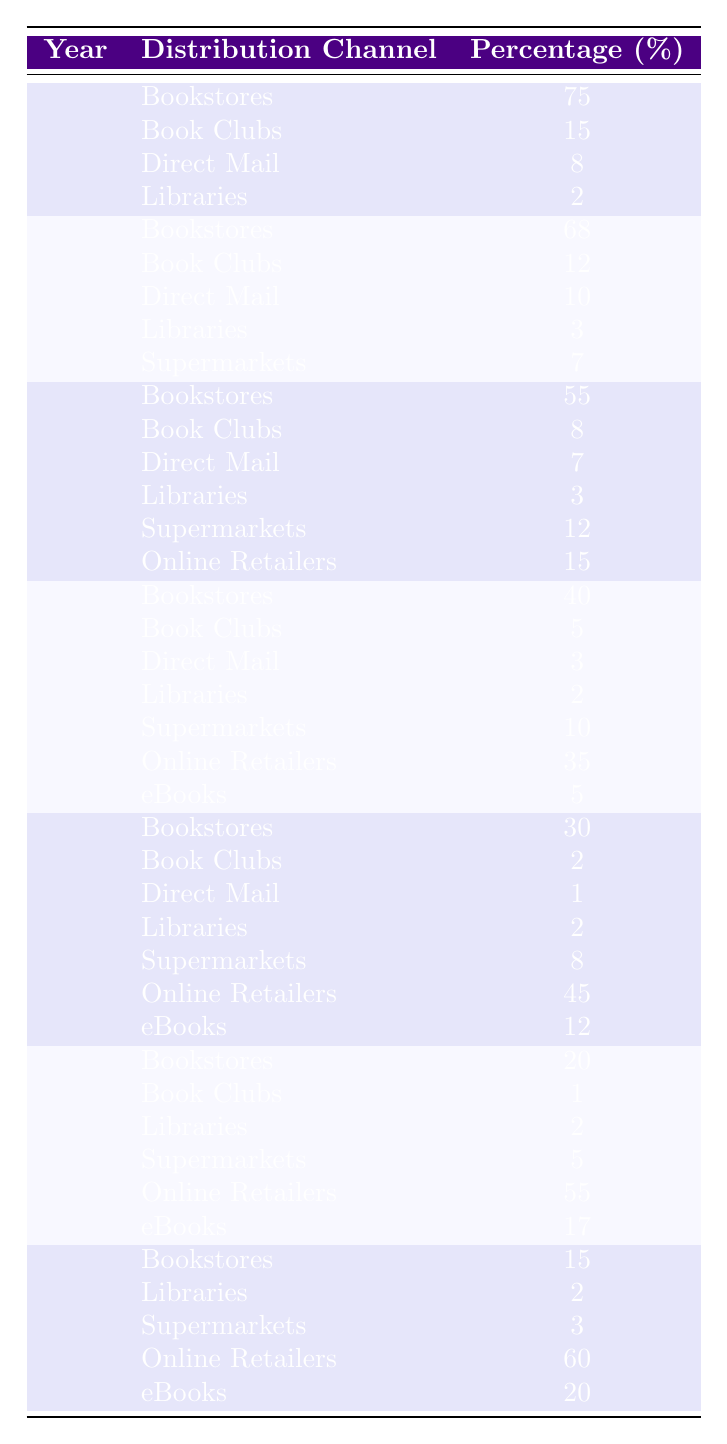What percentage of books were sold through bookstores in 1990? The table shows that in 1990, the percentage of books sold through bookstores was listed as 55%.
Answer: 55% In which year did online retailers first appear, and what was their percentage of books sold? Online retailers first appeared in 1990 with a percentage of 15% for books sold.
Answer: 1990, 15% What was the percentage increase in books sold through online retailers from 2000 to 2010? The percentage of books sold through online retailers was 35% in 2000 and increased to 45% in 2010. The increase is calculated as \(45 - 35 = 10\) percentage points.
Answer: 10 Which distribution channel had the highest percentage in 1980? In 1980, bookstores had the highest percentage of 68%.
Answer: 68% What was the reduction in percentage of books sold through bookstores from 1970 to 2023? The percentage of books sold through bookstores decreased from 75% in 1970 to 15% in 2023. The reduction is \(75 - 15 = 60\) percentage points.
Answer: 60 What is the total percentage of books sold through supermarkets across all years combined? The percentages for supermarkets across the years are: 0% (not listed in 1970 and 1980), 12% (1990), 10% (2000), 8% (2010), 5% (2020), and 3% (2023). The total is \(12 + 10 + 8 + 5 + 3 = 38\%.\)
Answer: 38% Which year saw the lowest percentage of books sold through libraries, and what was that percentage? The lowest percentage through libraries was 2%, which occurred in several years: 2000, 2010, 2020, and 2023, but was lower than in 1970 and 1980 (2% both).
Answer: 2%, 2000, 2010, 2020, 2023 What percentage of the books sold online in 2023 can be attributed to eBooks? In 2023, eBooks accounted for 20% of books sold.
Answer: 20% What is the average percentage of book sales through bookstores from 1970 to 2023? The percentages through bookstores are: 75% (1970), 68% (1980), 55% (1990), 40% (2000), 30% (2010), 20% (2020), and 15% (2023). The average is calculated as \((75 + 68 + 55 + 40 + 30 + 20 + 15) / 7 = 48.57\%\).
Answer: 48.57% In what year did the percentage of books sold through eBooks exceed that of direct mail for the first time, and what were those percentages? The first year where eBooks exceeded direct mail was 2000, where eBooks accounted for 5%, and direct mail 3%.
Answer: 2000, eBooks 5%, Direct Mail 3% What percentage of total sales in 2020 was attributed to online retailers? In 2020, the percentage of sales attributed to online retailers was 55%.
Answer: 55% 